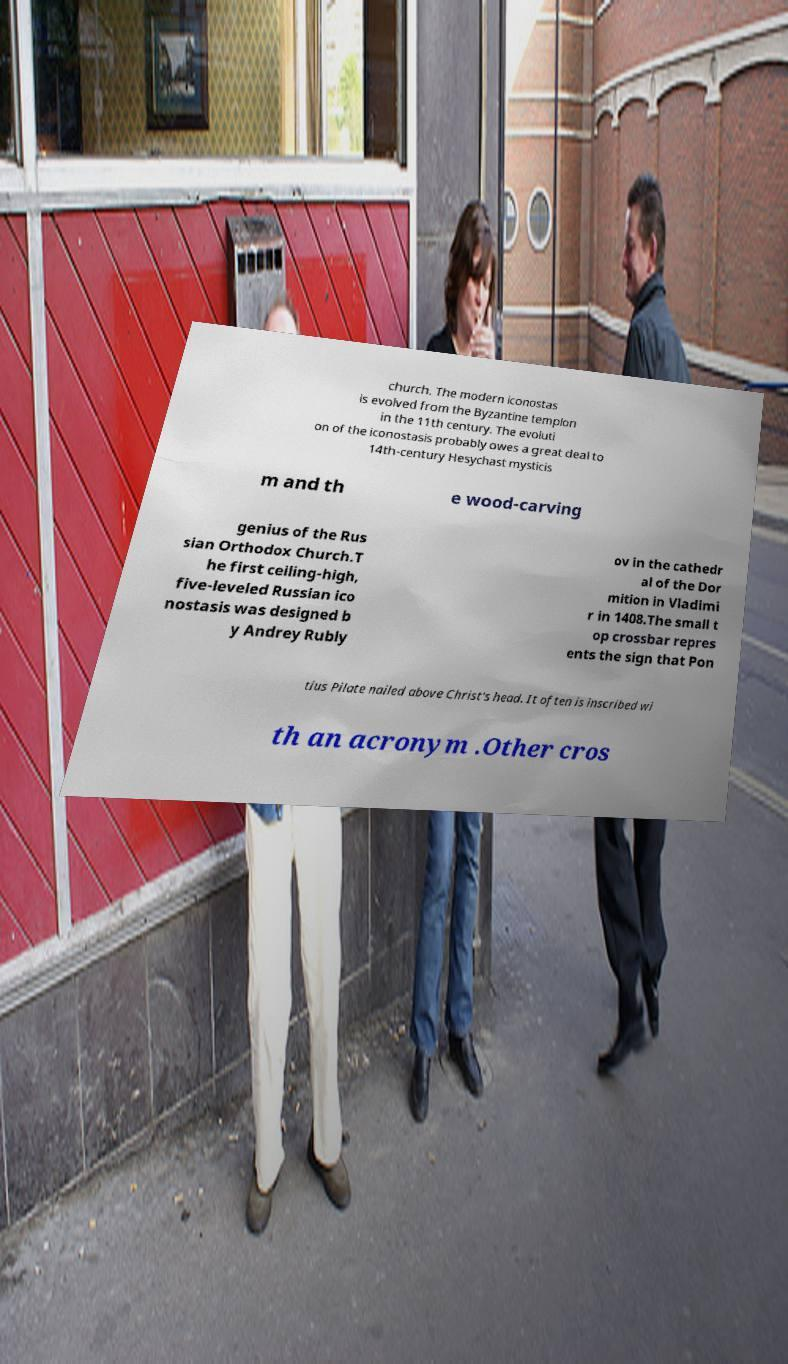Please identify and transcribe the text found in this image. church. The modern iconostas is evolved from the Byzantine templon in the 11th century. The evoluti on of the iconostasis probably owes a great deal to 14th-century Hesychast mysticis m and th e wood-carving genius of the Rus sian Orthodox Church.T he first ceiling-high, five-leveled Russian ico nostasis was designed b y Andrey Rubly ov in the cathedr al of the Dor mition in Vladimi r in 1408.The small t op crossbar repres ents the sign that Pon tius Pilate nailed above Christ's head. It often is inscribed wi th an acronym .Other cros 